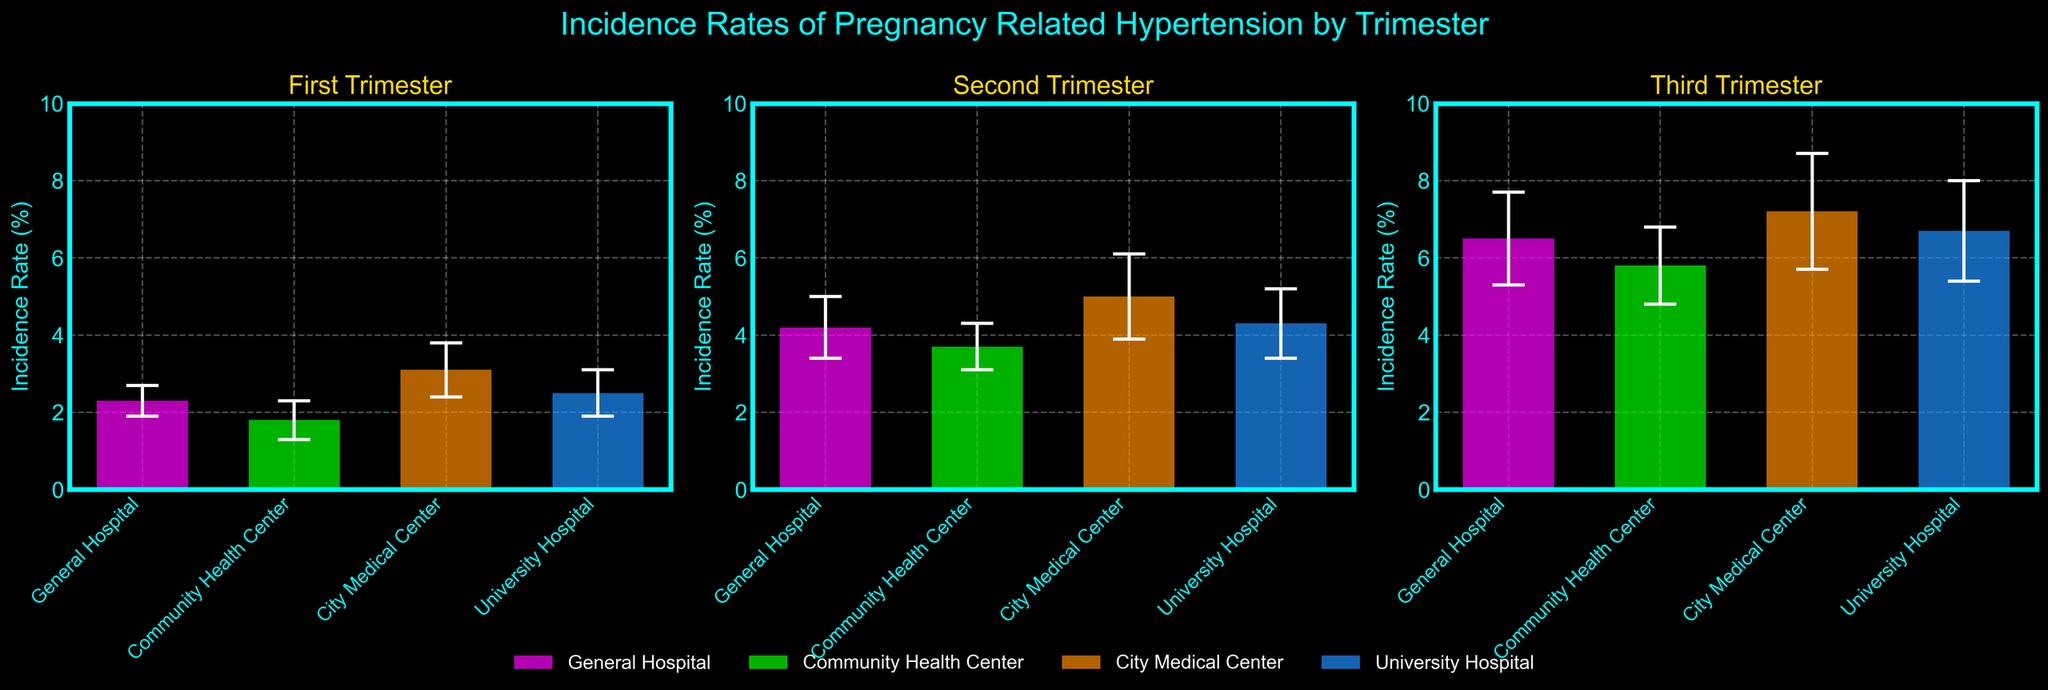What is the title of the figure? The title is written at the top of the figure in a larger font size compared to other text elements. It conveys the main subject of the figure.
Answer: Incidence Rates of Pregnancy Related Hypertension by Trimester Which trimester has the highest incidence rate of pregnancy-related hypertension at City Medical Center? Look at the bars representing the incidence rates for City Medical Center in each trimester. Identify the trimester where the bar reaches the highest point.
Answer: Third Trimester What are the incidence rates at General Hospital across all trimesters? Identify the bars corresponding to General Hospital in each subplot (trimester) and read the incidence rates from the bar heights.
Answer: 2.3%, 4.2%, 6.5% Which hospital shows the largest increase in incidence rate from the first to the third trimester? Calculate the difference in incidence rates between the first and third trimesters for each hospital. Compare the increases and identify the largest one.
Answer: General Hospital How do the error bars for University Hospital in the second trimester compare to the first trimester? Observe the length of the error bars (representing standard deviations) for University Hospital in both the first and second trimester subplots.
Answer: The error bars in the second trimester are larger What is the difference in incidence rate between University Hospital and Community Health Center in the third trimester? Check the heights of the bars for University Hospital and Community Health Center in the third trimester subplot. Subtract the smaller value from the larger one.
Answer: 0.9% On average, which trimester has the highest incidence rate of pregnancy-related hypertension across all hospitals? Calculate the average incidence rate for all hospitals in each trimester by summing the rates and dividing by the number of hospitals. Compare these averages to find the highest.
Answer: Third Trimester Which hospital has the smallest error bar in the second trimester? Examine the length of the error bars for each hospital in the second trimester subplot. Identify the shortest one.
Answer: Community Health Center What can be said about the trend in incidence rates of pregnancy-related hypertension as pregnancy progresses? Compare the incidence rates across the trimesters for a general overview. Note any patterns, such as whether rates increase or decrease moving from the first to the third trimester.
Answer: The incidence rates generally increase Which hospital has the most consistent incidence rates across all trimesters, considering both the rates and error bars? Evaluate the variation in incidence rates and the lengths of error bars for each hospital across all trimesters. Look for the hospital with the least variation and smallest error bars.
Answer: University Hospital 